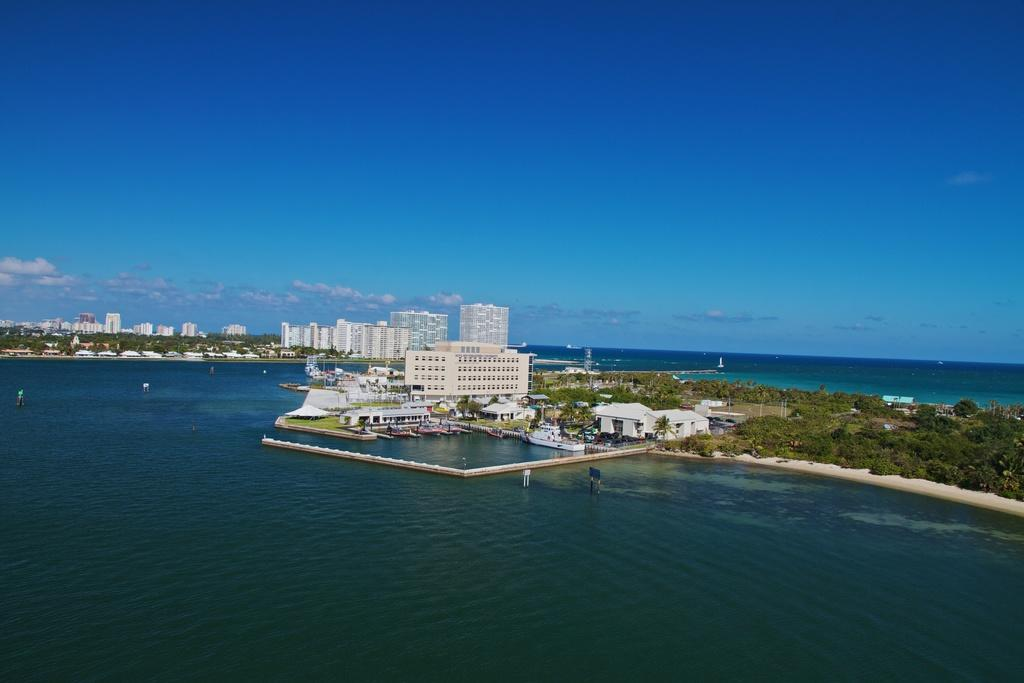What type of structures can be seen in the image? There are buildings in the image. What other natural elements are present in the image? There are trees and water visible in the image. Are there any vehicles or modes of transportation in the image? Yes, there are boats in the image. What is visible in the background of the image? The sky is visible in the image, and clouds are present in the sky. Can you tell me how many lawyers are involved in the fight happening near the water in the image? There is no fight or lawyer present in the image; it features buildings, trees, water, boats, and a sky with clouds. 